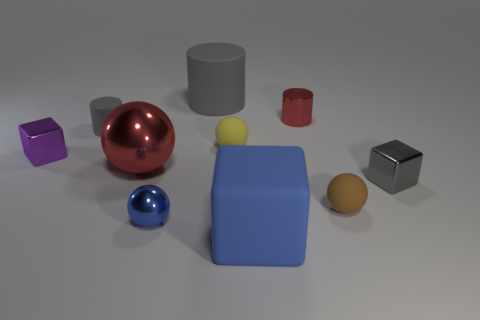Subtract all tiny metal cylinders. How many cylinders are left? 2 Subtract all purple blocks. How many blocks are left? 2 Subtract all brown spheres. How many gray cylinders are left? 2 Subtract 2 blocks. How many blocks are left? 1 Subtract all cylinders. How many objects are left? 7 Add 6 gray cylinders. How many gray cylinders are left? 8 Add 2 big gray matte cylinders. How many big gray matte cylinders exist? 3 Subtract 0 yellow cubes. How many objects are left? 10 Subtract all green spheres. Subtract all green cylinders. How many spheres are left? 4 Subtract all big things. Subtract all big blue blocks. How many objects are left? 6 